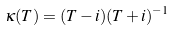Convert formula to latex. <formula><loc_0><loc_0><loc_500><loc_500>\kappa ( T ) = ( T - i ) ( T + i ) ^ { - 1 }</formula> 